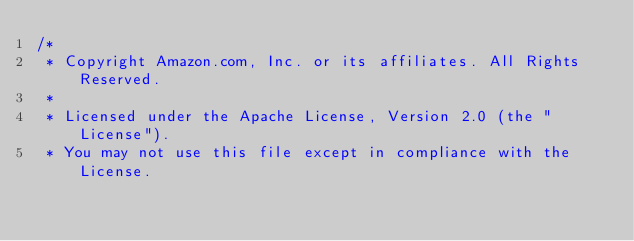<code> <loc_0><loc_0><loc_500><loc_500><_C#_>/*
 * Copyright Amazon.com, Inc. or its affiliates. All Rights Reserved.
 * 
 * Licensed under the Apache License, Version 2.0 (the "License").
 * You may not use this file except in compliance with the License.</code> 